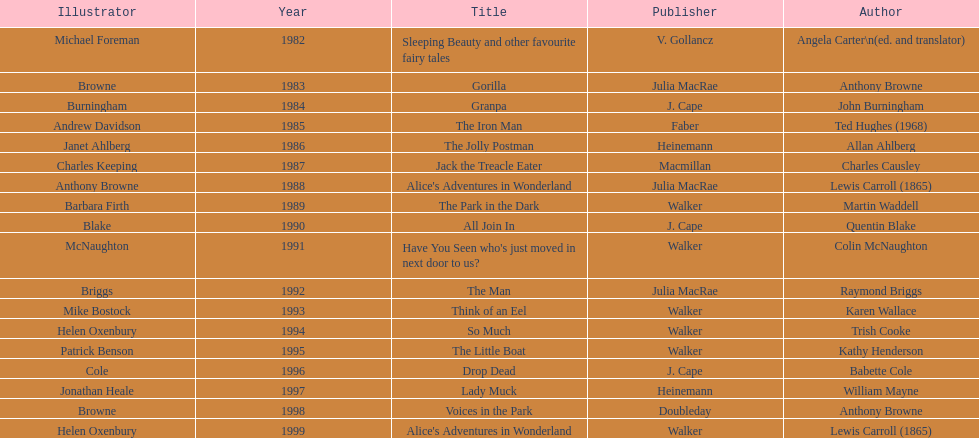What's the difference in years between angela carter's title and anthony browne's? 1. 